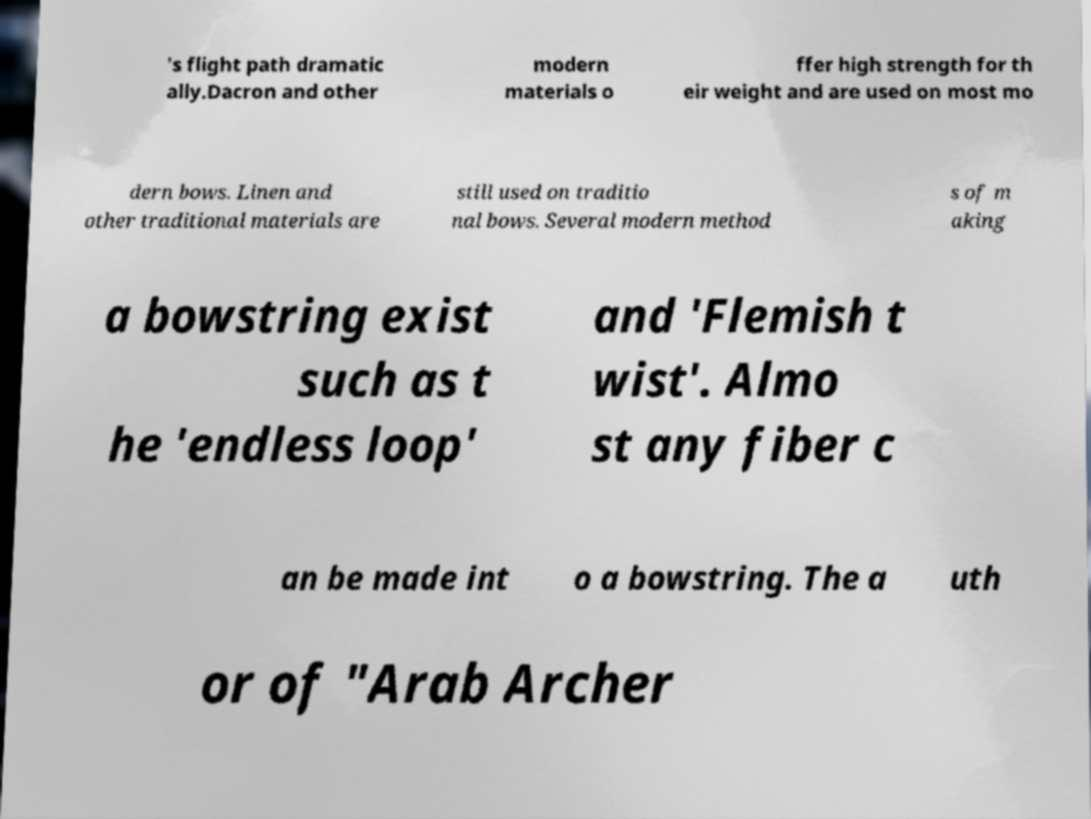I need the written content from this picture converted into text. Can you do that? 's flight path dramatic ally.Dacron and other modern materials o ffer high strength for th eir weight and are used on most mo dern bows. Linen and other traditional materials are still used on traditio nal bows. Several modern method s of m aking a bowstring exist such as t he 'endless loop' and 'Flemish t wist'. Almo st any fiber c an be made int o a bowstring. The a uth or of "Arab Archer 